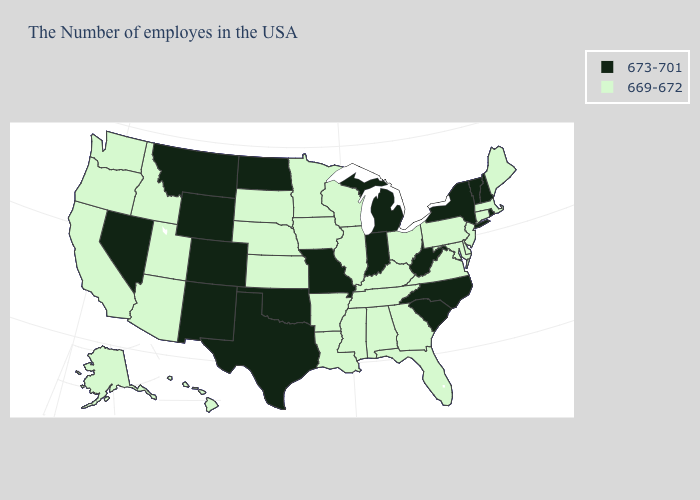What is the value of Tennessee?
Be succinct. 669-672. Name the states that have a value in the range 669-672?
Write a very short answer. Maine, Massachusetts, Connecticut, New Jersey, Delaware, Maryland, Pennsylvania, Virginia, Ohio, Florida, Georgia, Kentucky, Alabama, Tennessee, Wisconsin, Illinois, Mississippi, Louisiana, Arkansas, Minnesota, Iowa, Kansas, Nebraska, South Dakota, Utah, Arizona, Idaho, California, Washington, Oregon, Alaska, Hawaii. Name the states that have a value in the range 673-701?
Quick response, please. Rhode Island, New Hampshire, Vermont, New York, North Carolina, South Carolina, West Virginia, Michigan, Indiana, Missouri, Oklahoma, Texas, North Dakota, Wyoming, Colorado, New Mexico, Montana, Nevada. What is the value of New Mexico?
Keep it brief. 673-701. Name the states that have a value in the range 669-672?
Keep it brief. Maine, Massachusetts, Connecticut, New Jersey, Delaware, Maryland, Pennsylvania, Virginia, Ohio, Florida, Georgia, Kentucky, Alabama, Tennessee, Wisconsin, Illinois, Mississippi, Louisiana, Arkansas, Minnesota, Iowa, Kansas, Nebraska, South Dakota, Utah, Arizona, Idaho, California, Washington, Oregon, Alaska, Hawaii. Does Mississippi have the same value as Georgia?
Short answer required. Yes. Name the states that have a value in the range 673-701?
Answer briefly. Rhode Island, New Hampshire, Vermont, New York, North Carolina, South Carolina, West Virginia, Michigan, Indiana, Missouri, Oklahoma, Texas, North Dakota, Wyoming, Colorado, New Mexico, Montana, Nevada. What is the value of Kansas?
Give a very brief answer. 669-672. Does Iowa have the highest value in the MidWest?
Concise answer only. No. What is the lowest value in the USA?
Quick response, please. 669-672. Among the states that border Massachusetts , does Connecticut have the lowest value?
Write a very short answer. Yes. What is the value of New Jersey?
Keep it brief. 669-672. What is the value of Oregon?
Write a very short answer. 669-672. What is the value of Washington?
Short answer required. 669-672. 